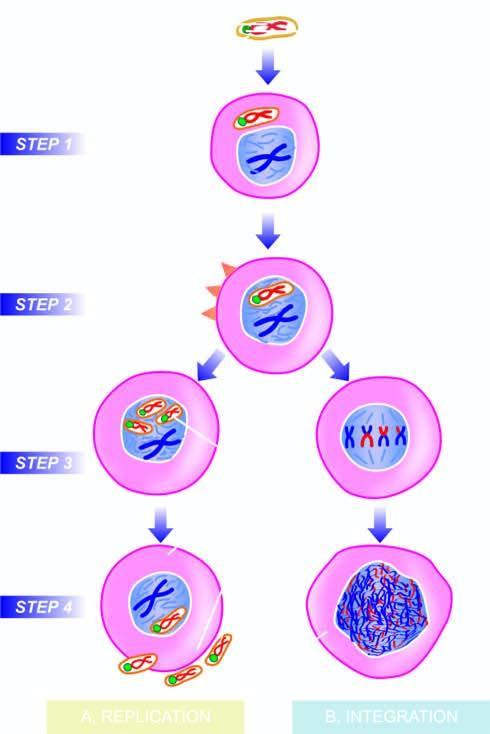what are formed?
Answer the question using a single word or phrase. Replication of viral dna occurs and other components of virion are formed 